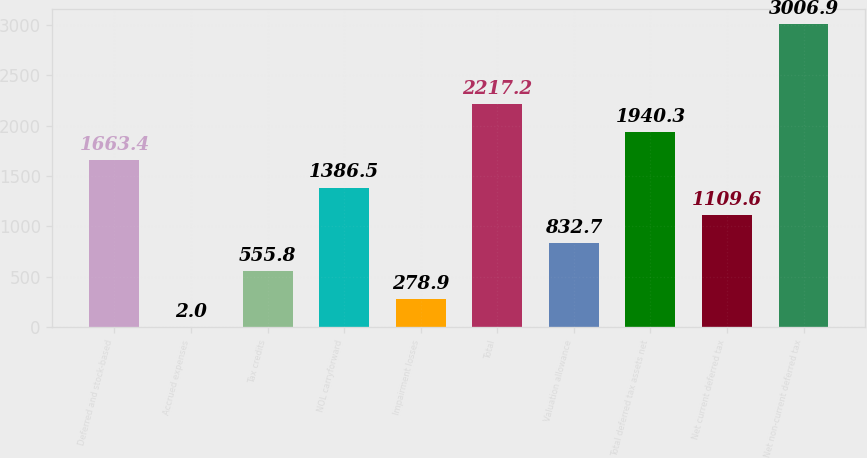<chart> <loc_0><loc_0><loc_500><loc_500><bar_chart><fcel>Deferred and stock-based<fcel>Accrued expenses<fcel>Tax credits<fcel>NOL carryforward<fcel>Impairment losses<fcel>Total<fcel>Valuation allowance<fcel>Total deferred tax assets net<fcel>Net current deferred tax<fcel>Net non-current deferred tax<nl><fcel>1663.4<fcel>2<fcel>555.8<fcel>1386.5<fcel>278.9<fcel>2217.2<fcel>832.7<fcel>1940.3<fcel>1109.6<fcel>3006.9<nl></chart> 